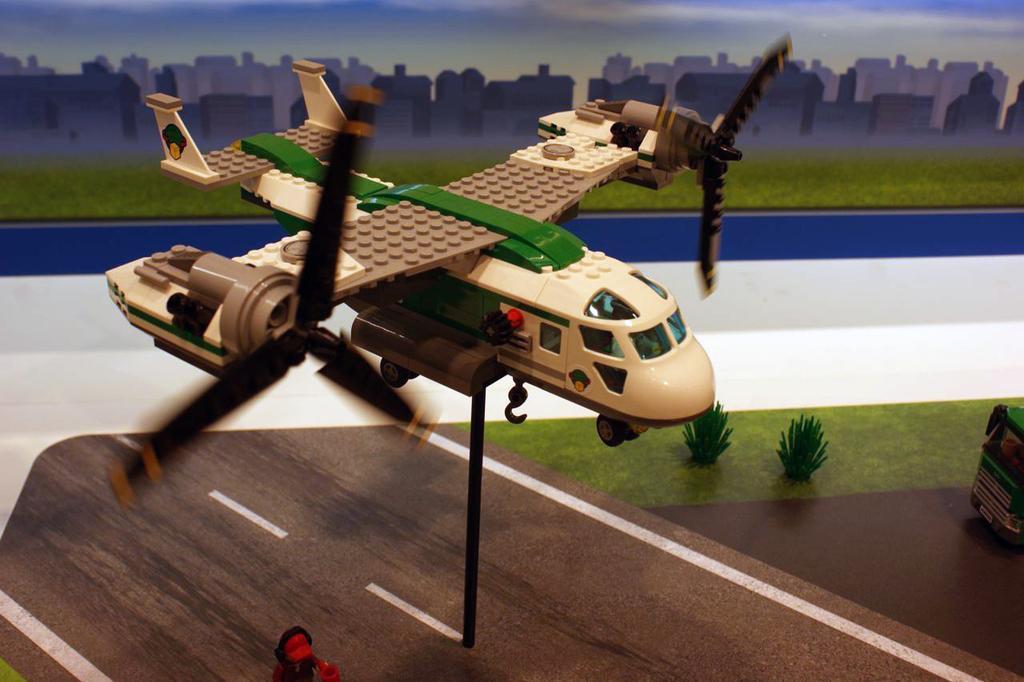Please provide a concise description of this image. In this image in the center there is one toy helicopter, and in the background there is an animation of some buildings and grass. At the bottom there is a wooden board, plants and some toys. 